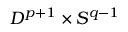<formula> <loc_0><loc_0><loc_500><loc_500>D ^ { p + 1 } \times S ^ { q - 1 }</formula> 